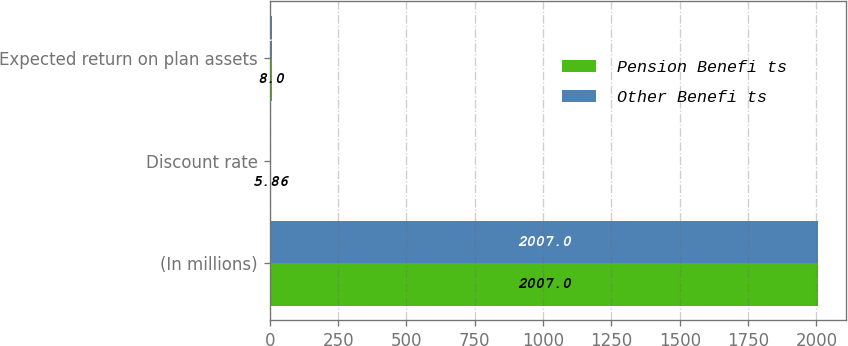<chart> <loc_0><loc_0><loc_500><loc_500><stacked_bar_chart><ecel><fcel>(In millions)<fcel>Discount rate<fcel>Expected return on plan assets<nl><fcel>Pension Benefi ts<fcel>2007<fcel>5.86<fcel>8<nl><fcel>Other Benefi ts<fcel>2007<fcel>5.84<fcel>8<nl></chart> 